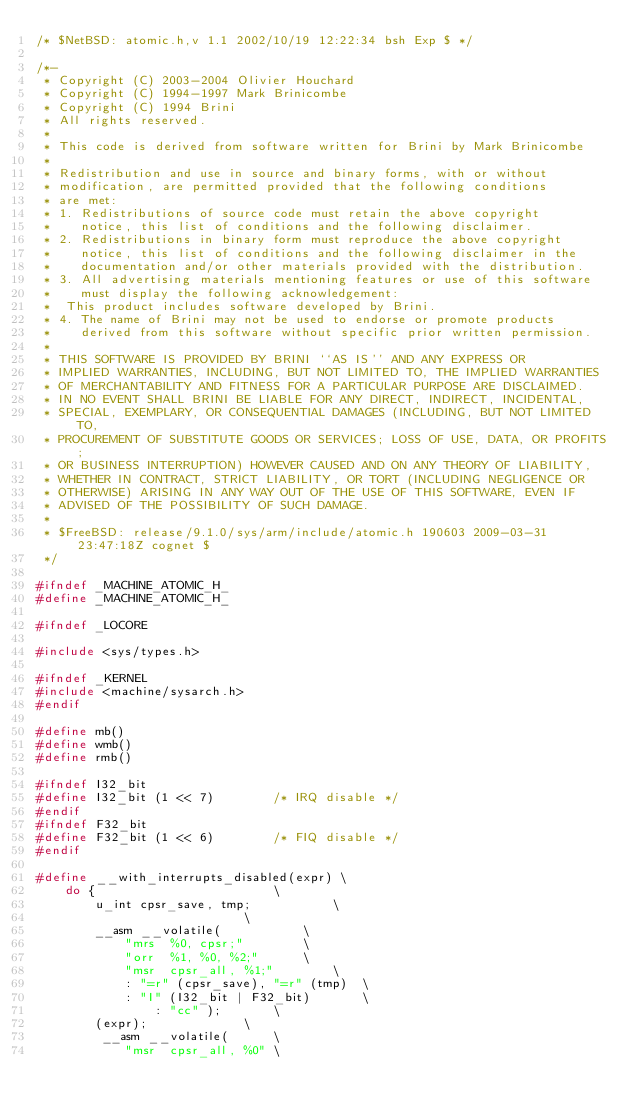<code> <loc_0><loc_0><loc_500><loc_500><_C_>/* $NetBSD: atomic.h,v 1.1 2002/10/19 12:22:34 bsh Exp $ */

/*-
 * Copyright (C) 2003-2004 Olivier Houchard
 * Copyright (C) 1994-1997 Mark Brinicombe
 * Copyright (C) 1994 Brini
 * All rights reserved.
 *
 * This code is derived from software written for Brini by Mark Brinicombe
 *
 * Redistribution and use in source and binary forms, with or without
 * modification, are permitted provided that the following conditions
 * are met:
 * 1. Redistributions of source code must retain the above copyright
 *    notice, this list of conditions and the following disclaimer.
 * 2. Redistributions in binary form must reproduce the above copyright
 *    notice, this list of conditions and the following disclaimer in the
 *    documentation and/or other materials provided with the distribution.
 * 3. All advertising materials mentioning features or use of this software
 *    must display the following acknowledgement:
 *	This product includes software developed by Brini.
 * 4. The name of Brini may not be used to endorse or promote products
 *    derived from this software without specific prior written permission.
 *
 * THIS SOFTWARE IS PROVIDED BY BRINI ``AS IS'' AND ANY EXPRESS OR
 * IMPLIED WARRANTIES, INCLUDING, BUT NOT LIMITED TO, THE IMPLIED WARRANTIES
 * OF MERCHANTABILITY AND FITNESS FOR A PARTICULAR PURPOSE ARE DISCLAIMED.
 * IN NO EVENT SHALL BRINI BE LIABLE FOR ANY DIRECT, INDIRECT, INCIDENTAL,
 * SPECIAL, EXEMPLARY, OR CONSEQUENTIAL DAMAGES (INCLUDING, BUT NOT LIMITED TO,
 * PROCUREMENT OF SUBSTITUTE GOODS OR SERVICES; LOSS OF USE, DATA, OR PROFITS;
 * OR BUSINESS INTERRUPTION) HOWEVER CAUSED AND ON ANY THEORY OF LIABILITY,
 * WHETHER IN CONTRACT, STRICT LIABILITY, OR TORT (INCLUDING NEGLIGENCE OR
 * OTHERWISE) ARISING IN ANY WAY OUT OF THE USE OF THIS SOFTWARE, EVEN IF
 * ADVISED OF THE POSSIBILITY OF SUCH DAMAGE.
 *
 * $FreeBSD: release/9.1.0/sys/arm/include/atomic.h 190603 2009-03-31 23:47:18Z cognet $
 */

#ifndef	_MACHINE_ATOMIC_H_
#define	_MACHINE_ATOMIC_H_

#ifndef _LOCORE

#include <sys/types.h>

#ifndef _KERNEL
#include <machine/sysarch.h>
#endif

#define	mb()
#define	wmb()
#define	rmb()

#ifndef I32_bit
#define I32_bit (1 << 7)        /* IRQ disable */
#endif
#ifndef F32_bit
#define F32_bit (1 << 6)        /* FIQ disable */
#endif

#define __with_interrupts_disabled(expr) \
	do {						\
		u_int cpsr_save, tmp;			\
							\
		__asm __volatile(			\
			"mrs  %0, cpsr;"		\
			"orr  %1, %0, %2;"		\
			"msr  cpsr_all, %1;"		\
			: "=r" (cpsr_save), "=r" (tmp)	\
			: "I" (I32_bit | F32_bit)		\
		        : "cc" );		\
		(expr);				\
		 __asm __volatile(		\
			"msr  cpsr_all, %0"	\</code> 